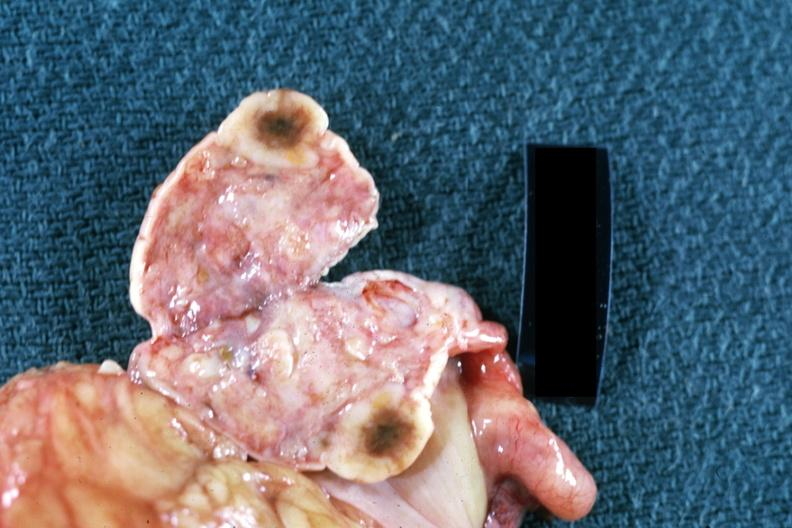what is present?
Answer the question using a single word or phrase. Metastatic carcinoma 